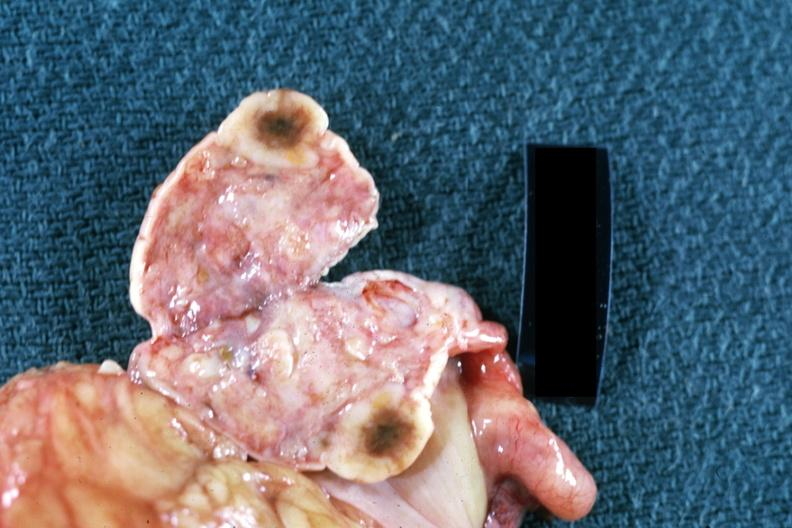what is present?
Answer the question using a single word or phrase. Metastatic carcinoma 